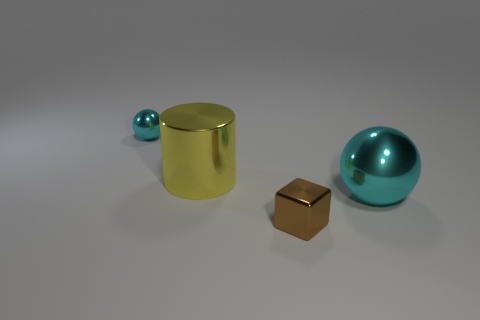Are the objects arranged in any particular pattern? The objects are arranged with some spacing between them, seemingly at random, without a discernible pattern. Each object is distinct and placed separately, highlighting its individuality. 